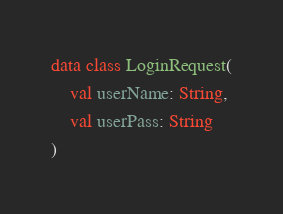<code> <loc_0><loc_0><loc_500><loc_500><_Kotlin_>
data class LoginRequest(
    val userName: String,
    val userPass: String
)
</code> 